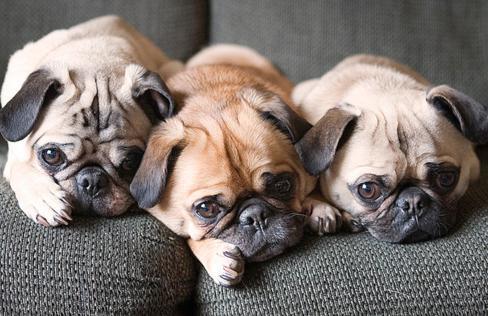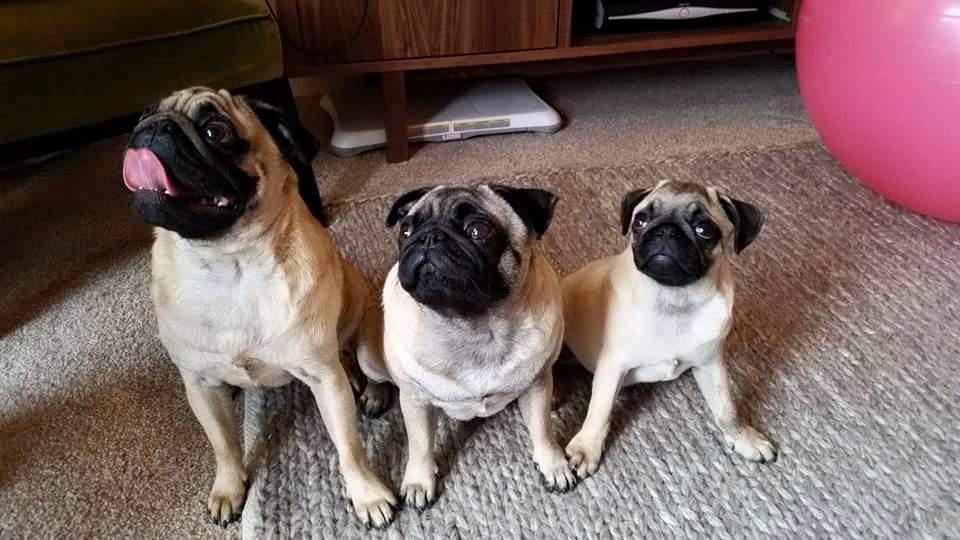The first image is the image on the left, the second image is the image on the right. Analyze the images presented: Is the assertion "There are at most two dogs." valid? Answer yes or no. No. The first image is the image on the left, the second image is the image on the right. For the images shown, is this caption "There is a single pug in each image." true? Answer yes or no. No. 